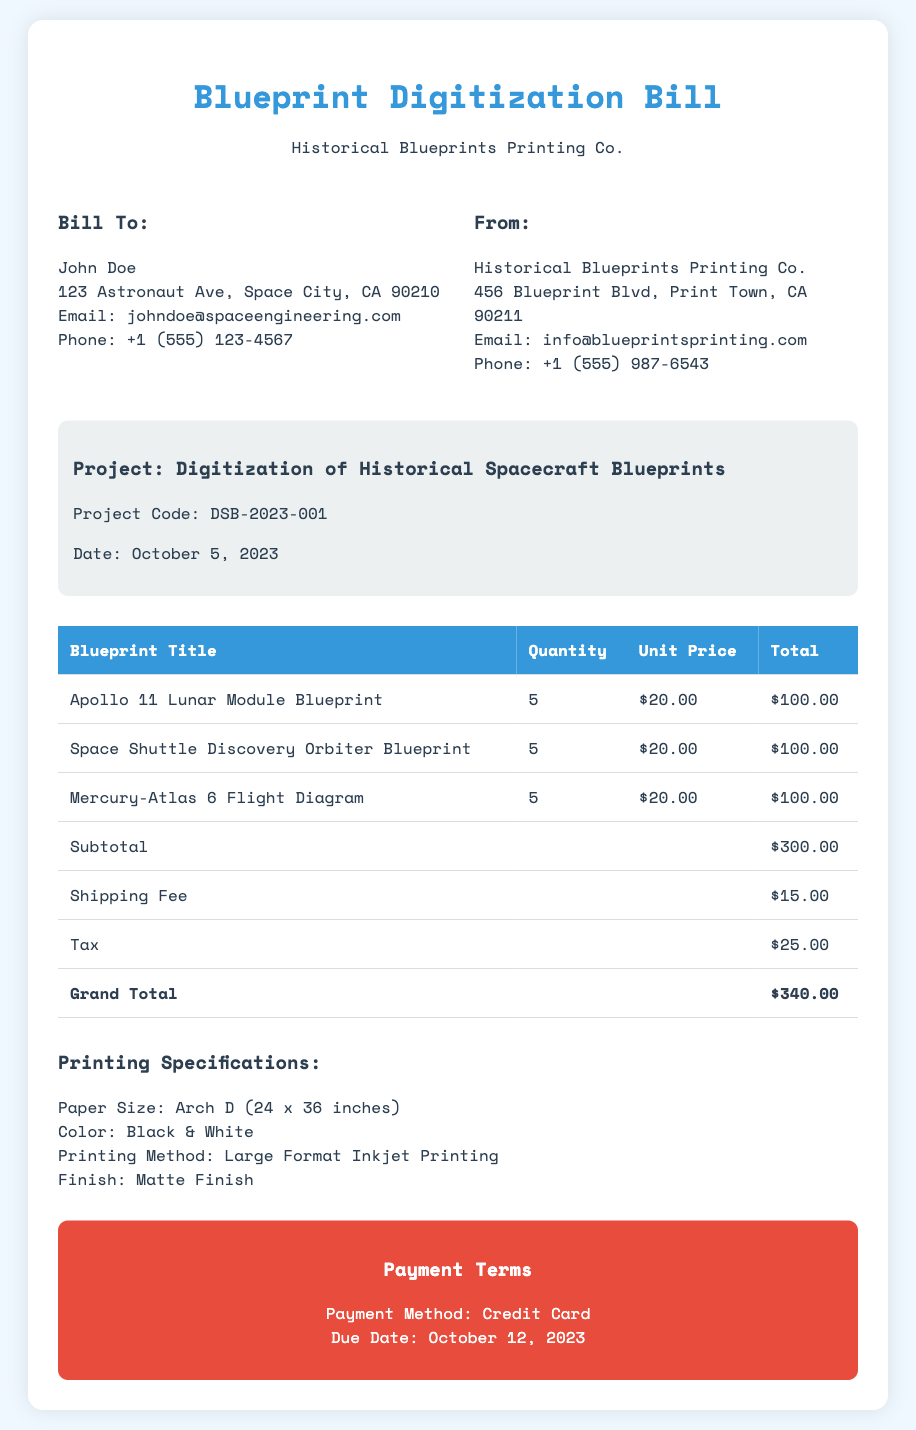what is the date of the bill? The date of the bill is clearly stated in the project details section.
Answer: October 5, 2023 who is the customer? The customer information is provided in the "Bill To" section of the document.
Answer: John Doe what is the paper size used for printing? The printing specifications section mentions the paper size used for printing.
Answer: Arch D (24 x 36 inches) how many copies of the Apollo 11 Lunar Module Blueprint are being printed? The quantity of each blueprint is shown in the table within the document.
Answer: 5 what is the total amount due? The grand total is calculated at the end of the table summarizing the costs.
Answer: $340.00 what is the shipping fee? The shipping fee is specified in the breakdown of costs in the table.
Answer: $15.00 what is the printing method used? The printing specifications section details the method used for printing.
Answer: Large Format Inkjet Printing when is the payment due? The payment terms provide the due date for the payment.
Answer: October 12, 2023 how much tax is applied to the bill? The amount of tax is also provided in the cost breakdown of the table.
Answer: $25.00 